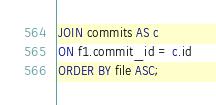Convert code to text. <code><loc_0><loc_0><loc_500><loc_500><_SQL_>JOIN commits AS c
ON f1.commit_id = c.id
ORDER BY file ASC;</code> 